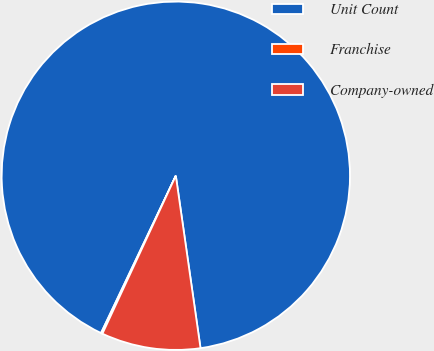<chart> <loc_0><loc_0><loc_500><loc_500><pie_chart><fcel>Unit Count<fcel>Franchise<fcel>Company-owned<nl><fcel>90.68%<fcel>0.14%<fcel>9.19%<nl></chart> 